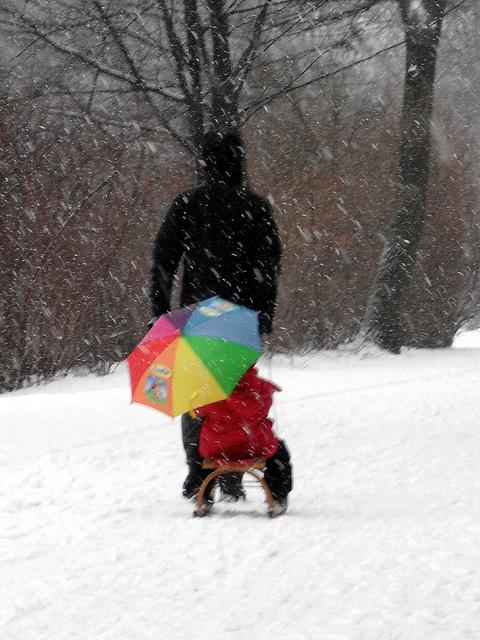In which location might this umbrella be appropriate?

Choices:
A) veterans parade
B) klan rally
C) volcano
D) pride parade pride parade 